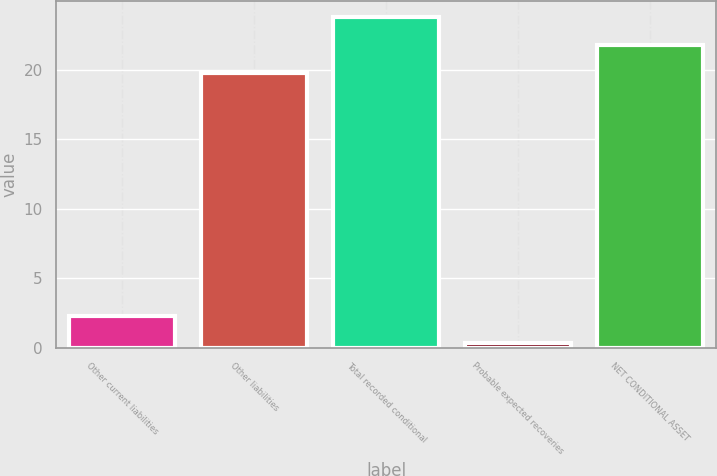<chart> <loc_0><loc_0><loc_500><loc_500><bar_chart><fcel>Other current liabilities<fcel>Other liabilities<fcel>Total recorded conditional<fcel>Probable expected recoveries<fcel>NET CONDITIONAL ASSET<nl><fcel>2.29<fcel>19.8<fcel>23.78<fcel>0.3<fcel>21.79<nl></chart> 